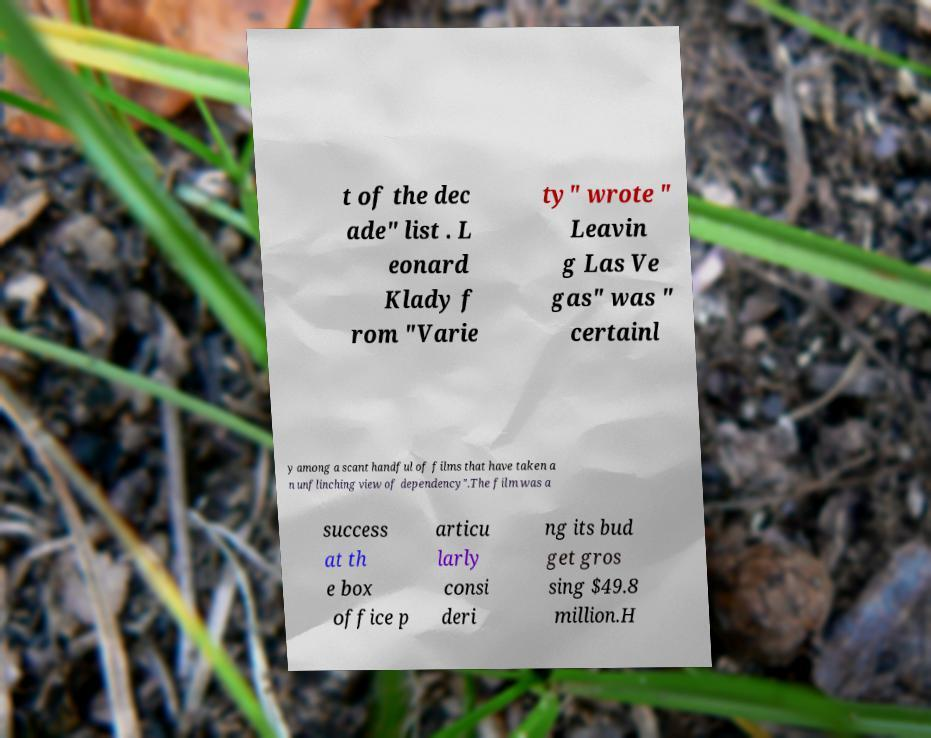There's text embedded in this image that I need extracted. Can you transcribe it verbatim? t of the dec ade" list . L eonard Klady f rom "Varie ty" wrote " Leavin g Las Ve gas" was " certainl y among a scant handful of films that have taken a n unflinching view of dependency".The film was a success at th e box office p articu larly consi deri ng its bud get gros sing $49.8 million.H 